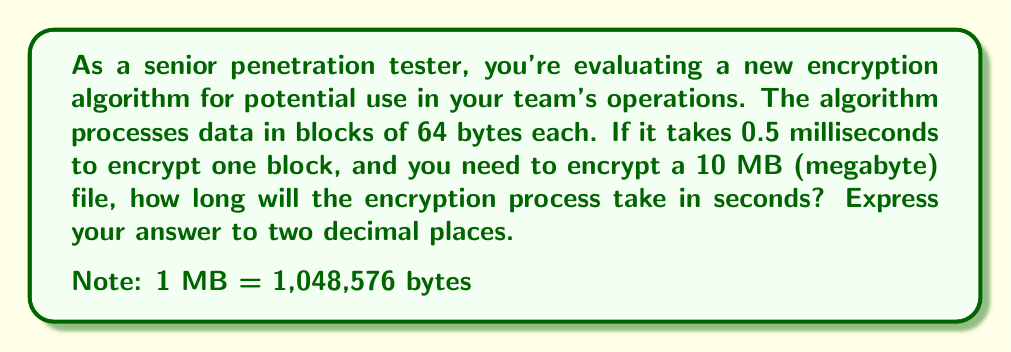Show me your answer to this math problem. Let's break this problem down step-by-step:

1) First, we need to calculate how many blocks are in a 10 MB file:
   
   $$ \text{Number of blocks} = \frac{\text{File size in bytes}}{\text{Block size in bytes}} $$

   $$ \text{Number of blocks} = \frac{10 \times 1,048,576}{64} = 163,840 \text{ blocks} $$

2) Now, we know that it takes 0.5 milliseconds to encrypt one block. Let's calculate the total time in milliseconds:

   $$ \text{Total time (ms)} = \text{Number of blocks} \times \text{Time per block (ms)} $$
   $$ \text{Total time (ms)} = 163,840 \times 0.5 = 81,920 \text{ ms} $$

3) We need to convert this to seconds:

   $$ \text{Total time (s)} = \frac{\text{Total time (ms)}}{1000} $$
   $$ \text{Total time (s)} = \frac{81,920}{1000} = 81.92 \text{ seconds} $$

4) The question asks for the answer to two decimal places, which is already the case here.
Answer: 81.92 seconds 